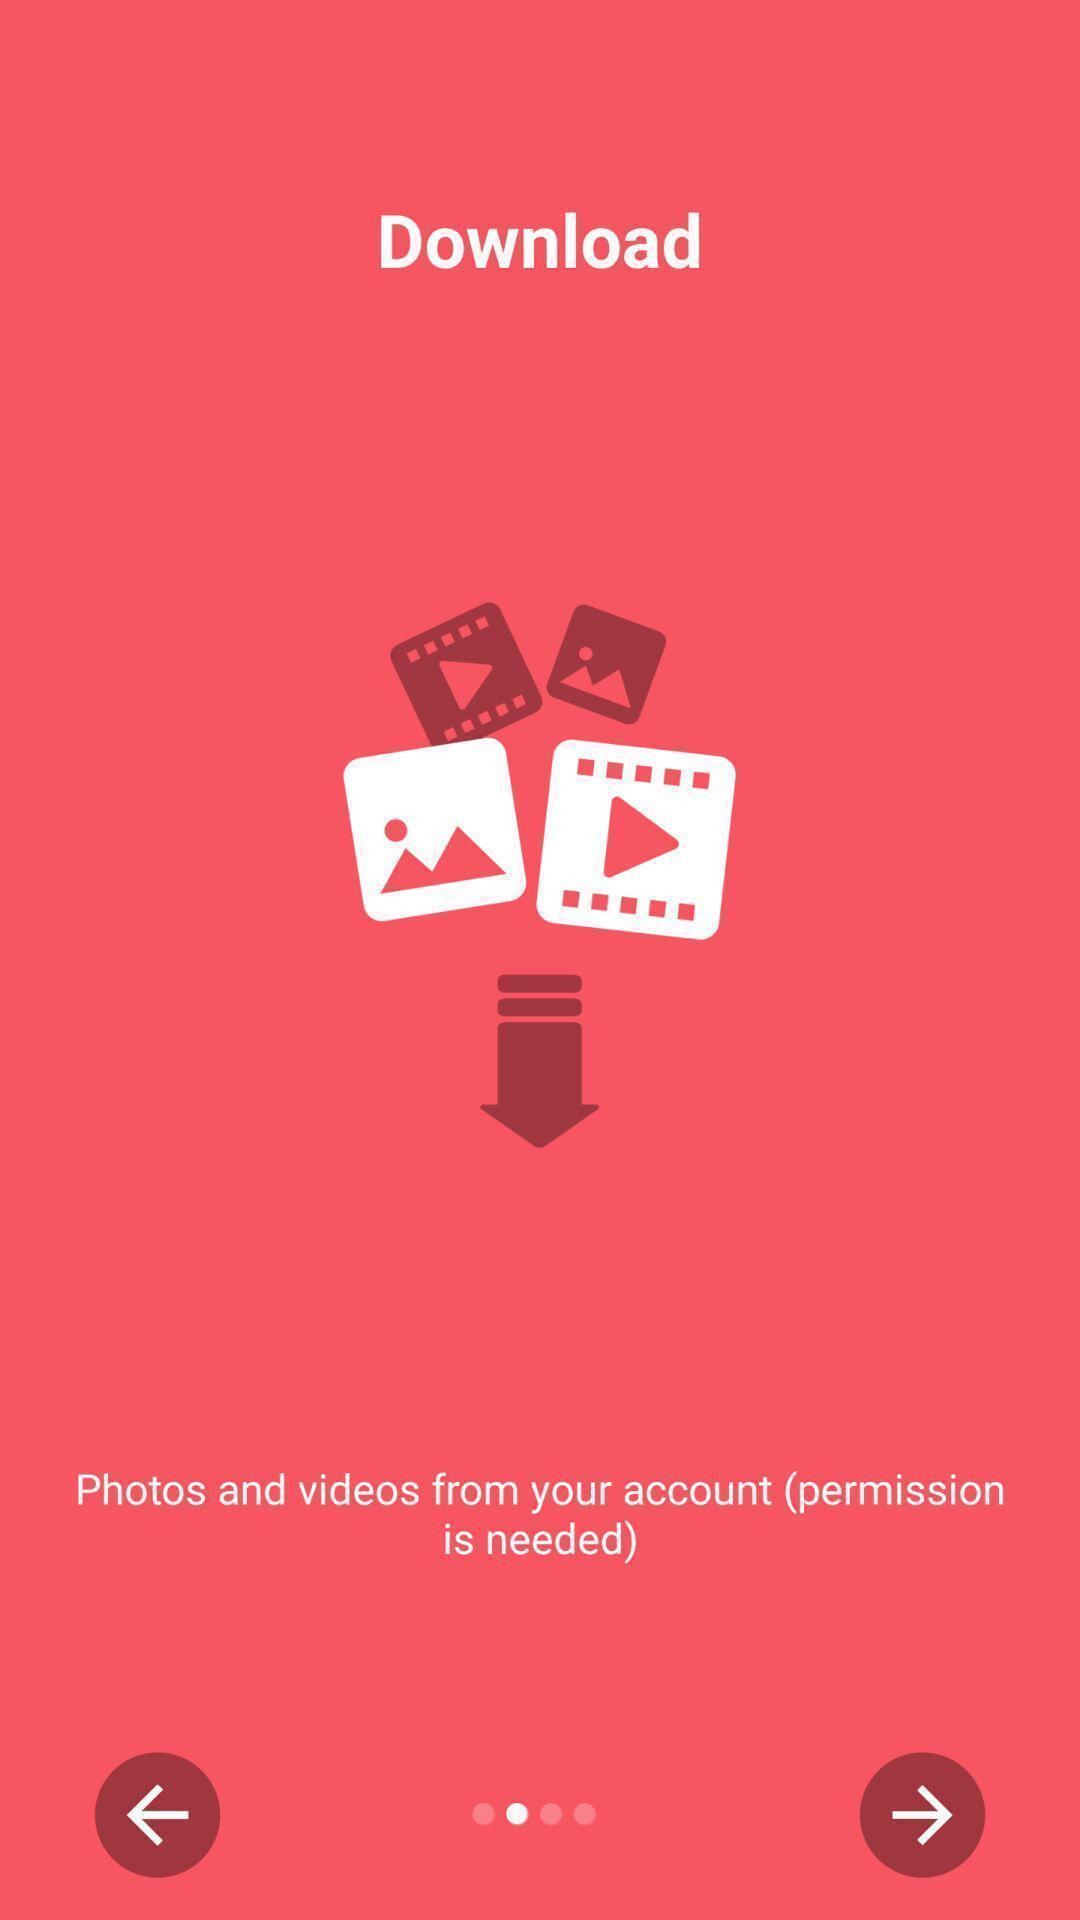Tell me what you see in this picture. Screen page displaying various icons. 